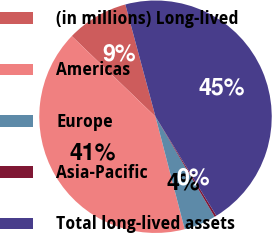Convert chart to OTSL. <chart><loc_0><loc_0><loc_500><loc_500><pie_chart><fcel>(in millions) Long-lived<fcel>Americas<fcel>Europe<fcel>Asia-Pacific<fcel>Total long-lived assets<nl><fcel>8.62%<fcel>41.24%<fcel>4.45%<fcel>0.28%<fcel>45.41%<nl></chart> 